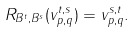Convert formula to latex. <formula><loc_0><loc_0><loc_500><loc_500>R _ { B ^ { t } , B ^ { s } } ( v _ { p , q } ^ { t , s } ) = v _ { p , q } ^ { s , t } .</formula> 